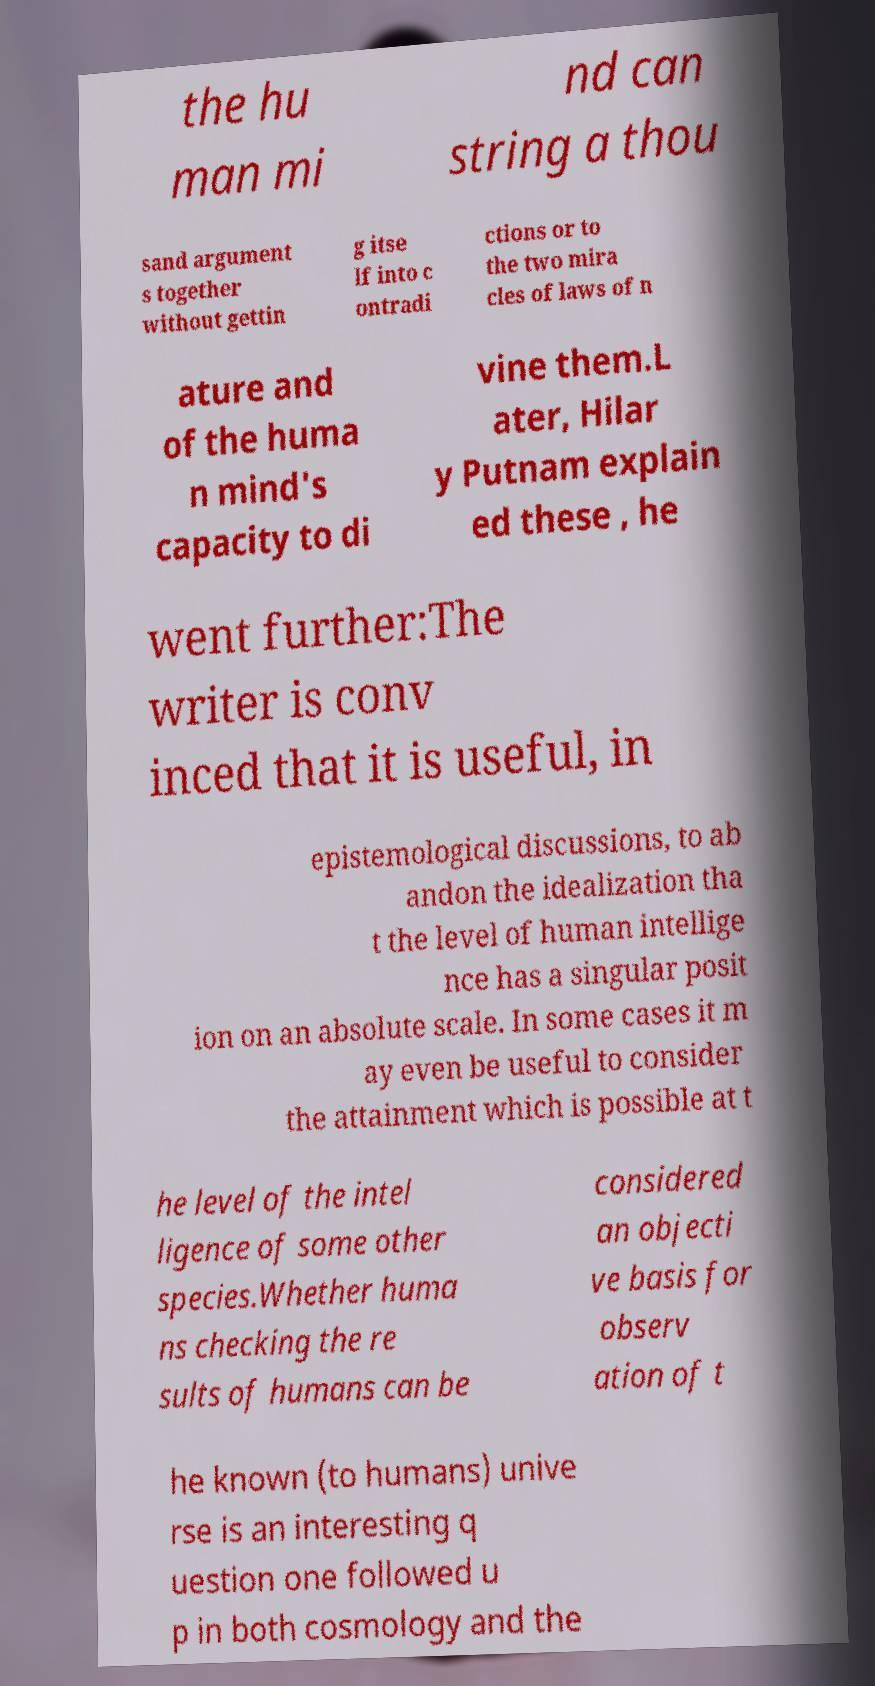I need the written content from this picture converted into text. Can you do that? the hu man mi nd can string a thou sand argument s together without gettin g itse lf into c ontradi ctions or to the two mira cles of laws of n ature and of the huma n mind's capacity to di vine them.L ater, Hilar y Putnam explain ed these , he went further:The writer is conv inced that it is useful, in epistemological discussions, to ab andon the idealization tha t the level of human intellige nce has a singular posit ion on an absolute scale. In some cases it m ay even be useful to consider the attainment which is possible at t he level of the intel ligence of some other species.Whether huma ns checking the re sults of humans can be considered an objecti ve basis for observ ation of t he known (to humans) unive rse is an interesting q uestion one followed u p in both cosmology and the 